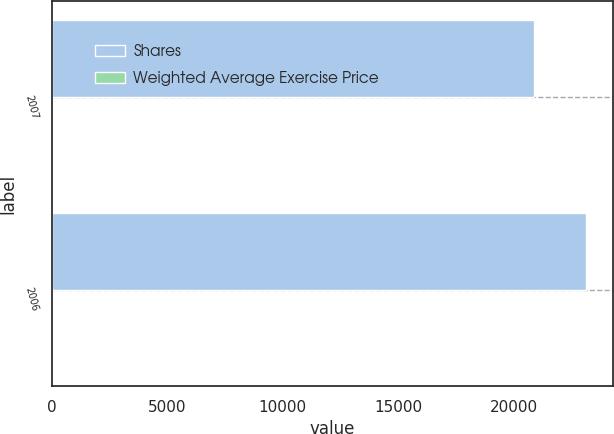<chart> <loc_0><loc_0><loc_500><loc_500><stacked_bar_chart><ecel><fcel>2007<fcel>2006<nl><fcel>Shares<fcel>20909<fcel>23136<nl><fcel>Weighted Average Exercise Price<fcel>13.72<fcel>14.05<nl></chart> 